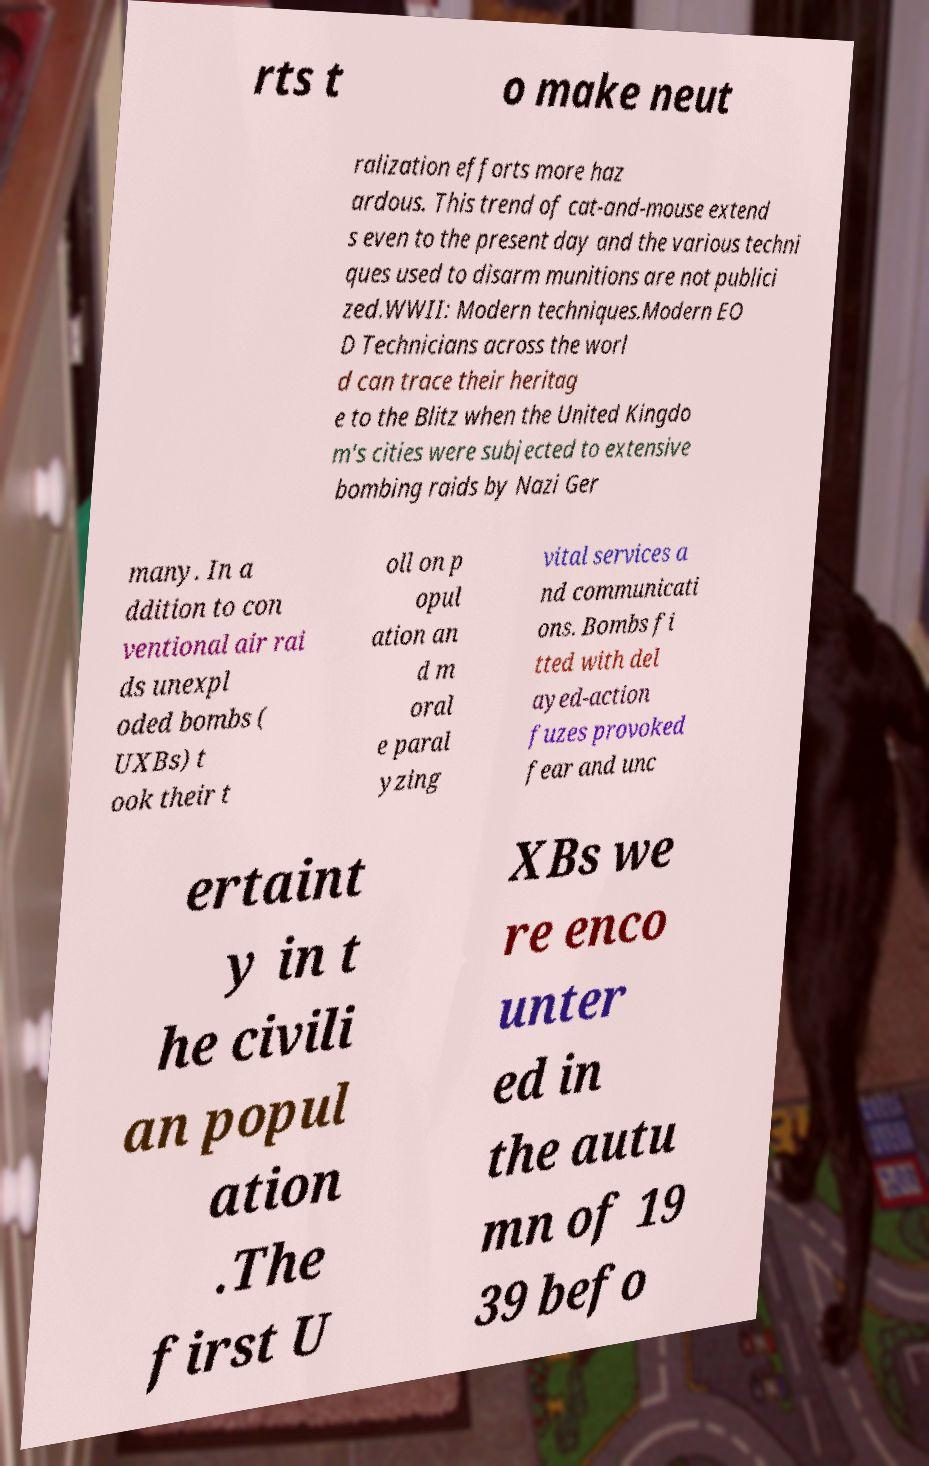I need the written content from this picture converted into text. Can you do that? rts t o make neut ralization efforts more haz ardous. This trend of cat-and-mouse extend s even to the present day and the various techni ques used to disarm munitions are not publici zed.WWII: Modern techniques.Modern EO D Technicians across the worl d can trace their heritag e to the Blitz when the United Kingdo m's cities were subjected to extensive bombing raids by Nazi Ger many. In a ddition to con ventional air rai ds unexpl oded bombs ( UXBs) t ook their t oll on p opul ation an d m oral e paral yzing vital services a nd communicati ons. Bombs fi tted with del ayed-action fuzes provoked fear and unc ertaint y in t he civili an popul ation .The first U XBs we re enco unter ed in the autu mn of 19 39 befo 